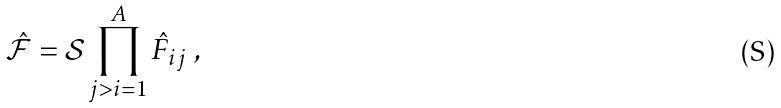Convert formula to latex. <formula><loc_0><loc_0><loc_500><loc_500>\mathcal { \hat { F } } = \mathcal { S } \prod _ { j > i = 1 } ^ { A } \hat { F } _ { i j } \ ,</formula> 